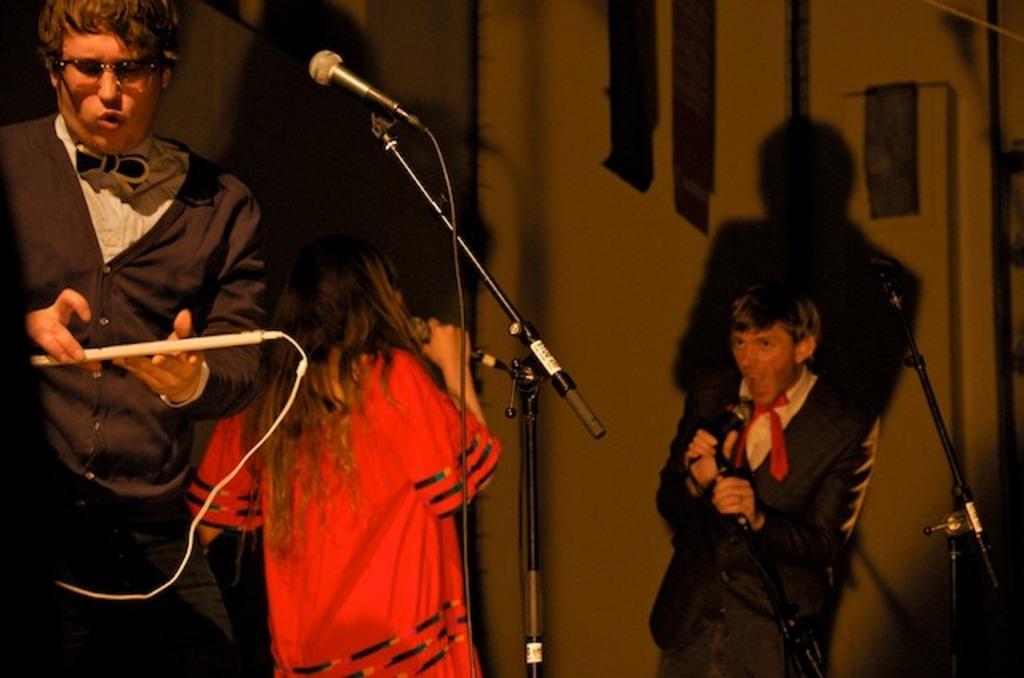Could you give a brief overview of what you see in this image? This picture shows few people standing and we see a man and a woman singing with the help of microphones and we see another man holding a instrument in his hand. 